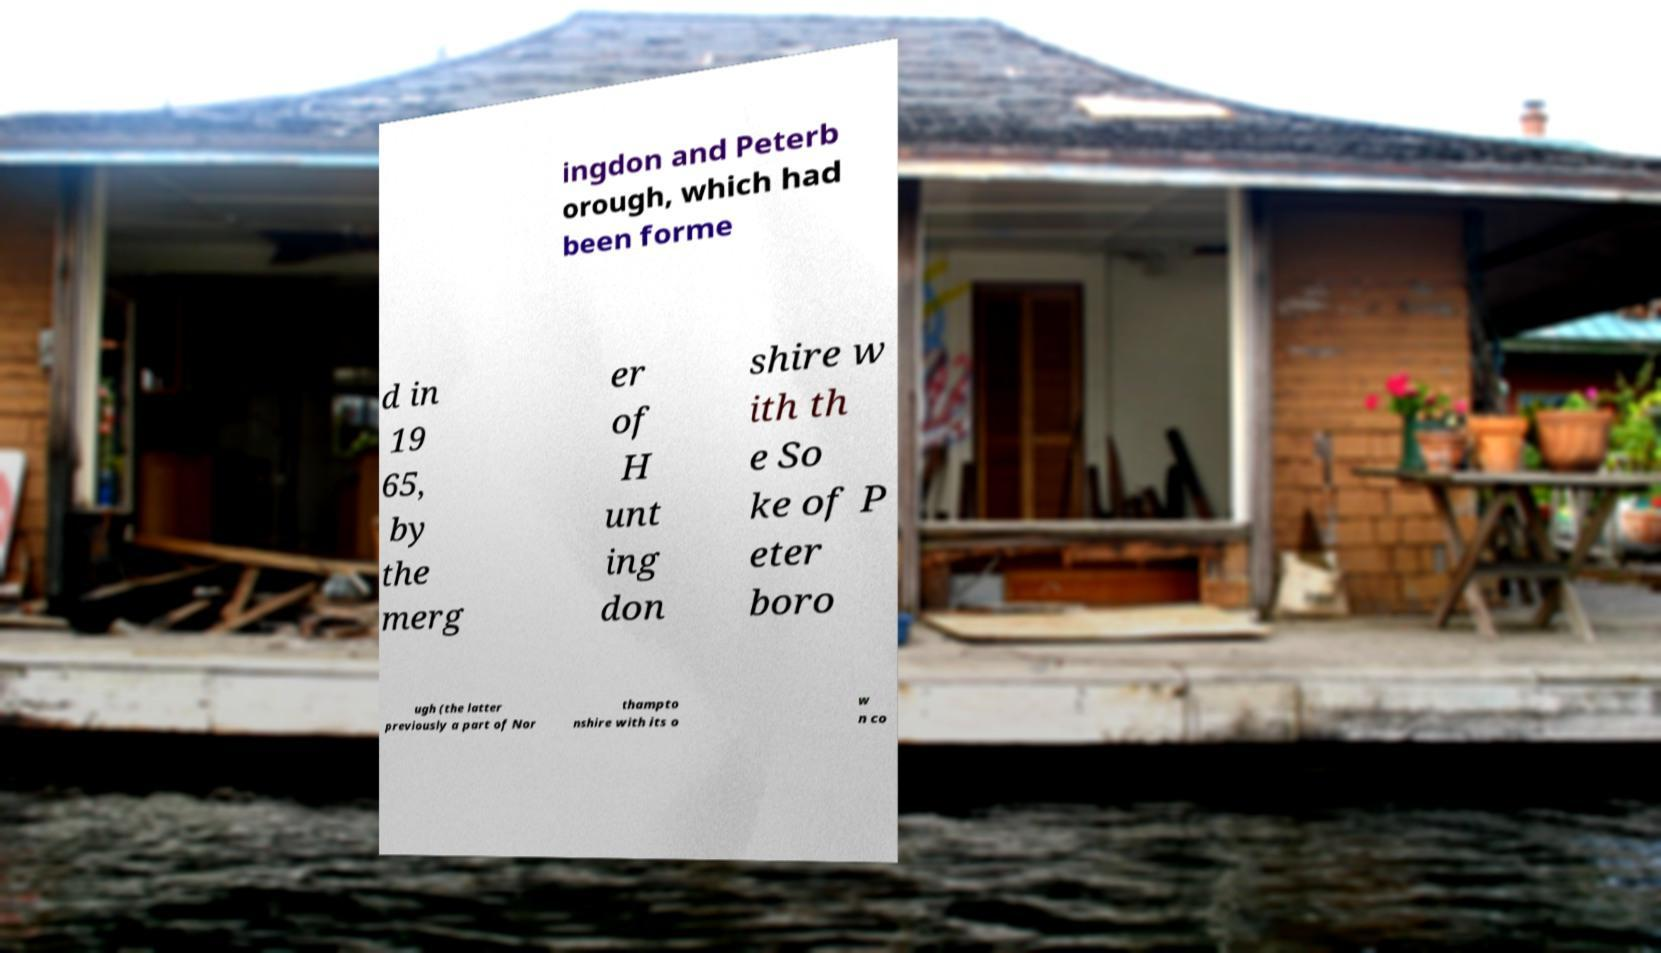For documentation purposes, I need the text within this image transcribed. Could you provide that? ingdon and Peterb orough, which had been forme d in 19 65, by the merg er of H unt ing don shire w ith th e So ke of P eter boro ugh (the latter previously a part of Nor thampto nshire with its o w n co 